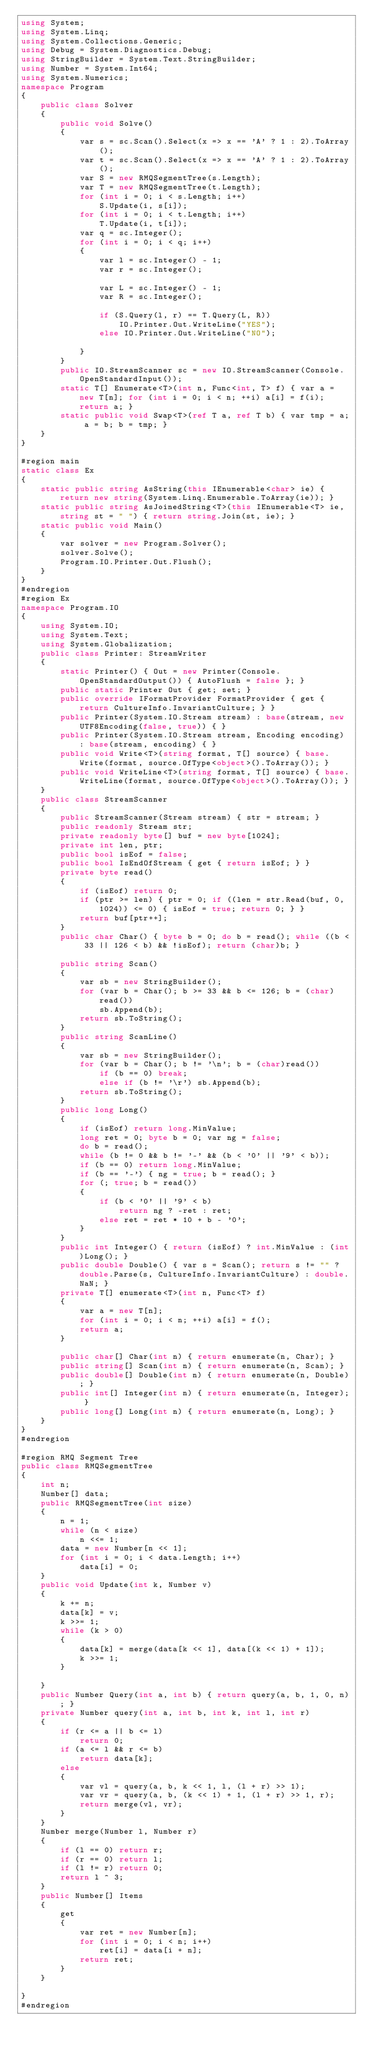Convert code to text. <code><loc_0><loc_0><loc_500><loc_500><_C#_>using System;
using System.Linq;
using System.Collections.Generic;
using Debug = System.Diagnostics.Debug;
using StringBuilder = System.Text.StringBuilder;
using Number = System.Int64;
using System.Numerics;
namespace Program
{
    public class Solver
    {
        public void Solve()
        {
            var s = sc.Scan().Select(x => x == 'A' ? 1 : 2).ToArray();
            var t = sc.Scan().Select(x => x == 'A' ? 1 : 2).ToArray();
            var S = new RMQSegmentTree(s.Length);
            var T = new RMQSegmentTree(t.Length);
            for (int i = 0; i < s.Length; i++)
                S.Update(i, s[i]);
            for (int i = 0; i < t.Length; i++)
                T.Update(i, t[i]);
            var q = sc.Integer();
            for (int i = 0; i < q; i++)
            {
                var l = sc.Integer() - 1;
                var r = sc.Integer();

                var L = sc.Integer() - 1;
                var R = sc.Integer();

                if (S.Query(l, r) == T.Query(L, R))
                    IO.Printer.Out.WriteLine("YES");
                else IO.Printer.Out.WriteLine("NO");

            }
        }
        public IO.StreamScanner sc = new IO.StreamScanner(Console.OpenStandardInput());
        static T[] Enumerate<T>(int n, Func<int, T> f) { var a = new T[n]; for (int i = 0; i < n; ++i) a[i] = f(i); return a; }
        static public void Swap<T>(ref T a, ref T b) { var tmp = a; a = b; b = tmp; }
    }
}

#region main
static class Ex
{
    static public string AsString(this IEnumerable<char> ie) { return new string(System.Linq.Enumerable.ToArray(ie)); }
    static public string AsJoinedString<T>(this IEnumerable<T> ie, string st = " ") { return string.Join(st, ie); }
    static public void Main()
    {
        var solver = new Program.Solver();
        solver.Solve();
        Program.IO.Printer.Out.Flush();
    }
}
#endregion
#region Ex
namespace Program.IO
{
    using System.IO;
    using System.Text;
    using System.Globalization;
    public class Printer: StreamWriter
    {
        static Printer() { Out = new Printer(Console.OpenStandardOutput()) { AutoFlush = false }; }
        public static Printer Out { get; set; }
        public override IFormatProvider FormatProvider { get { return CultureInfo.InvariantCulture; } }
        public Printer(System.IO.Stream stream) : base(stream, new UTF8Encoding(false, true)) { }
        public Printer(System.IO.Stream stream, Encoding encoding) : base(stream, encoding) { }
        public void Write<T>(string format, T[] source) { base.Write(format, source.OfType<object>().ToArray()); }
        public void WriteLine<T>(string format, T[] source) { base.WriteLine(format, source.OfType<object>().ToArray()); }
    }
    public class StreamScanner
    {
        public StreamScanner(Stream stream) { str = stream; }
        public readonly Stream str;
        private readonly byte[] buf = new byte[1024];
        private int len, ptr;
        public bool isEof = false;
        public bool IsEndOfStream { get { return isEof; } }
        private byte read()
        {
            if (isEof) return 0;
            if (ptr >= len) { ptr = 0; if ((len = str.Read(buf, 0, 1024)) <= 0) { isEof = true; return 0; } }
            return buf[ptr++];
        }
        public char Char() { byte b = 0; do b = read(); while ((b < 33 || 126 < b) && !isEof); return (char)b; }

        public string Scan()
        {
            var sb = new StringBuilder();
            for (var b = Char(); b >= 33 && b <= 126; b = (char)read())
                sb.Append(b);
            return sb.ToString();
        }
        public string ScanLine()
        {
            var sb = new StringBuilder();
            for (var b = Char(); b != '\n'; b = (char)read())
                if (b == 0) break;
                else if (b != '\r') sb.Append(b);
            return sb.ToString();
        }
        public long Long()
        {
            if (isEof) return long.MinValue;
            long ret = 0; byte b = 0; var ng = false;
            do b = read();
            while (b != 0 && b != '-' && (b < '0' || '9' < b));
            if (b == 0) return long.MinValue;
            if (b == '-') { ng = true; b = read(); }
            for (; true; b = read())
            {
                if (b < '0' || '9' < b)
                    return ng ? -ret : ret;
                else ret = ret * 10 + b - '0';
            }
        }
        public int Integer() { return (isEof) ? int.MinValue : (int)Long(); }
        public double Double() { var s = Scan(); return s != "" ? double.Parse(s, CultureInfo.InvariantCulture) : double.NaN; }
        private T[] enumerate<T>(int n, Func<T> f)
        {
            var a = new T[n];
            for (int i = 0; i < n; ++i) a[i] = f();
            return a;
        }

        public char[] Char(int n) { return enumerate(n, Char); }
        public string[] Scan(int n) { return enumerate(n, Scan); }
        public double[] Double(int n) { return enumerate(n, Double); }
        public int[] Integer(int n) { return enumerate(n, Integer); }
        public long[] Long(int n) { return enumerate(n, Long); }
    }
}
#endregion

#region RMQ Segment Tree
public class RMQSegmentTree
{
    int n;
    Number[] data;
    public RMQSegmentTree(int size)
    {
        n = 1;
        while (n < size)
            n <<= 1;
        data = new Number[n << 1];
        for (int i = 0; i < data.Length; i++)
            data[i] = 0;
    }
    public void Update(int k, Number v)
    {
        k += n;
        data[k] = v;
        k >>= 1;
        while (k > 0)
        {
            data[k] = merge(data[k << 1], data[(k << 1) + 1]);
            k >>= 1;
        }

    }
    public Number Query(int a, int b) { return query(a, b, 1, 0, n); }
    private Number query(int a, int b, int k, int l, int r)
    {
        if (r <= a || b <= l)
            return 0;
        if (a <= l && r <= b)
            return data[k];
        else
        {
            var vl = query(a, b, k << 1, l, (l + r) >> 1);
            var vr = query(a, b, (k << 1) + 1, (l + r) >> 1, r);
            return merge(vl, vr);
        }
    }
    Number merge(Number l, Number r)
    {
        if (l == 0) return r;
        if (r == 0) return l;
        if (l != r) return 0;
        return l ^ 3;
    }
    public Number[] Items
    {
        get
        {
            var ret = new Number[n];
            for (int i = 0; i < n; i++)
                ret[i] = data[i + n];
            return ret;
        }
    }

}
#endregion

</code> 